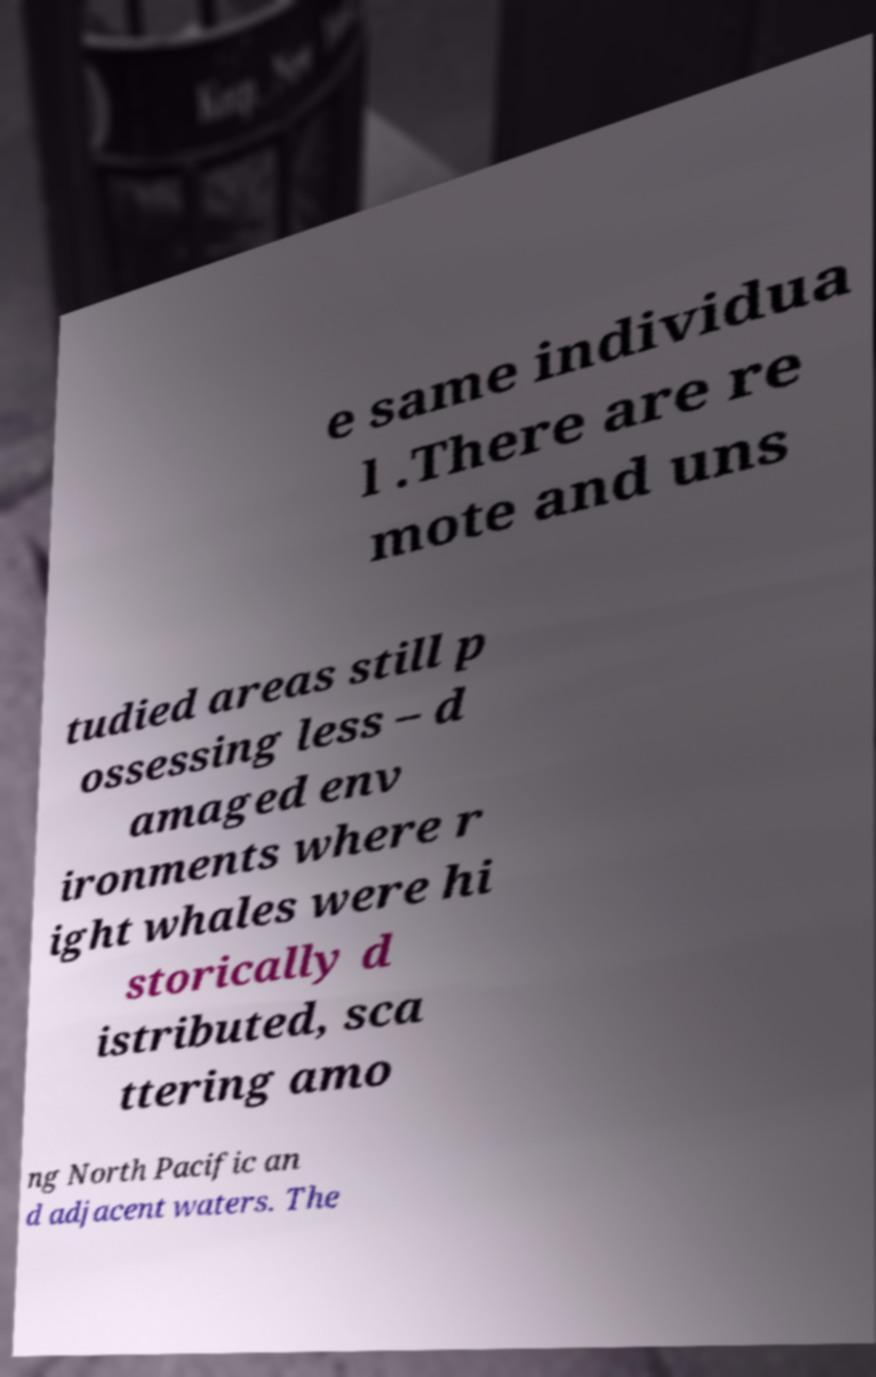Can you accurately transcribe the text from the provided image for me? e same individua l .There are re mote and uns tudied areas still p ossessing less – d amaged env ironments where r ight whales were hi storically d istributed, sca ttering amo ng North Pacific an d adjacent waters. The 